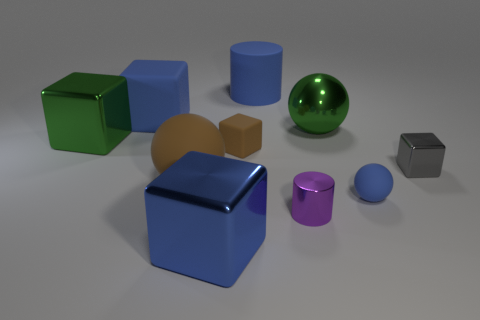What is the color of the tiny object that is behind the tiny cylinder and on the left side of the green shiny ball?
Provide a succinct answer. Brown. What is the shape of the matte thing that is the same size as the blue ball?
Make the answer very short. Cube. Are there any large objects that have the same color as the big cylinder?
Your answer should be very brief. Yes. Are there an equal number of tiny rubber cubes behind the green metal block and blue matte things?
Offer a terse response. No. Does the tiny rubber sphere have the same color as the big rubber cube?
Your answer should be compact. Yes. There is a shiny block that is behind the blue metallic block and to the left of the big blue cylinder; how big is it?
Ensure brevity in your answer.  Large. What color is the cylinder that is the same material as the big brown ball?
Give a very brief answer. Blue. How many blocks have the same material as the large brown sphere?
Provide a succinct answer. 2. Is the number of big balls behind the small brown rubber block the same as the number of tiny brown things behind the big green shiny ball?
Provide a short and direct response. No. There is a gray thing; is its shape the same as the blue object that is in front of the tiny ball?
Offer a very short reply. Yes. 